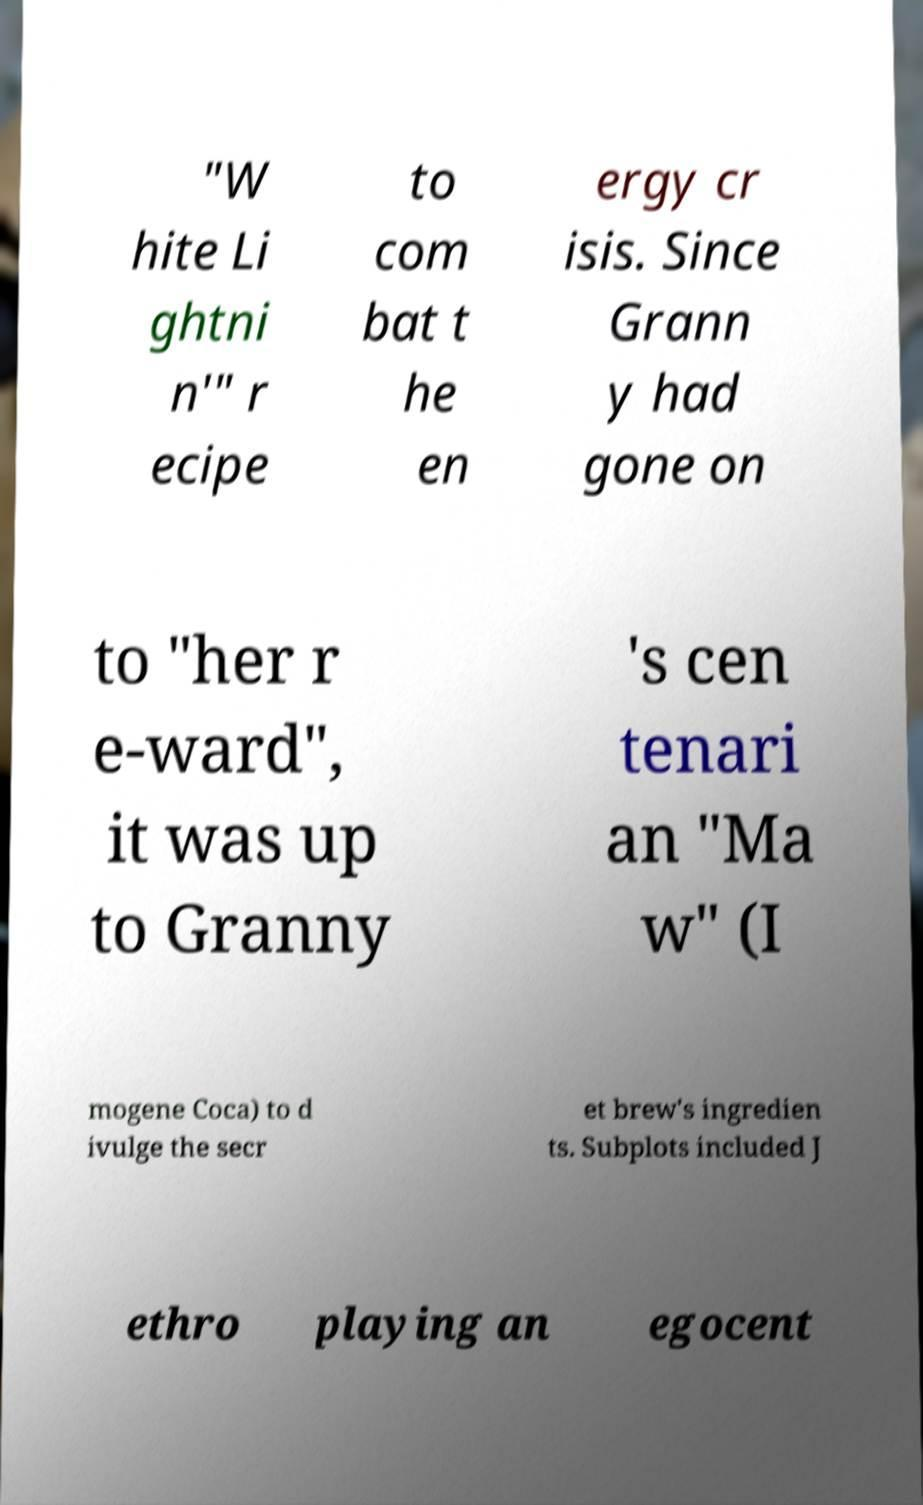Please identify and transcribe the text found in this image. "W hite Li ghtni n'" r ecipe to com bat t he en ergy cr isis. Since Grann y had gone on to "her r e-ward", it was up to Granny 's cen tenari an "Ma w" (I mogene Coca) to d ivulge the secr et brew's ingredien ts. Subplots included J ethro playing an egocent 